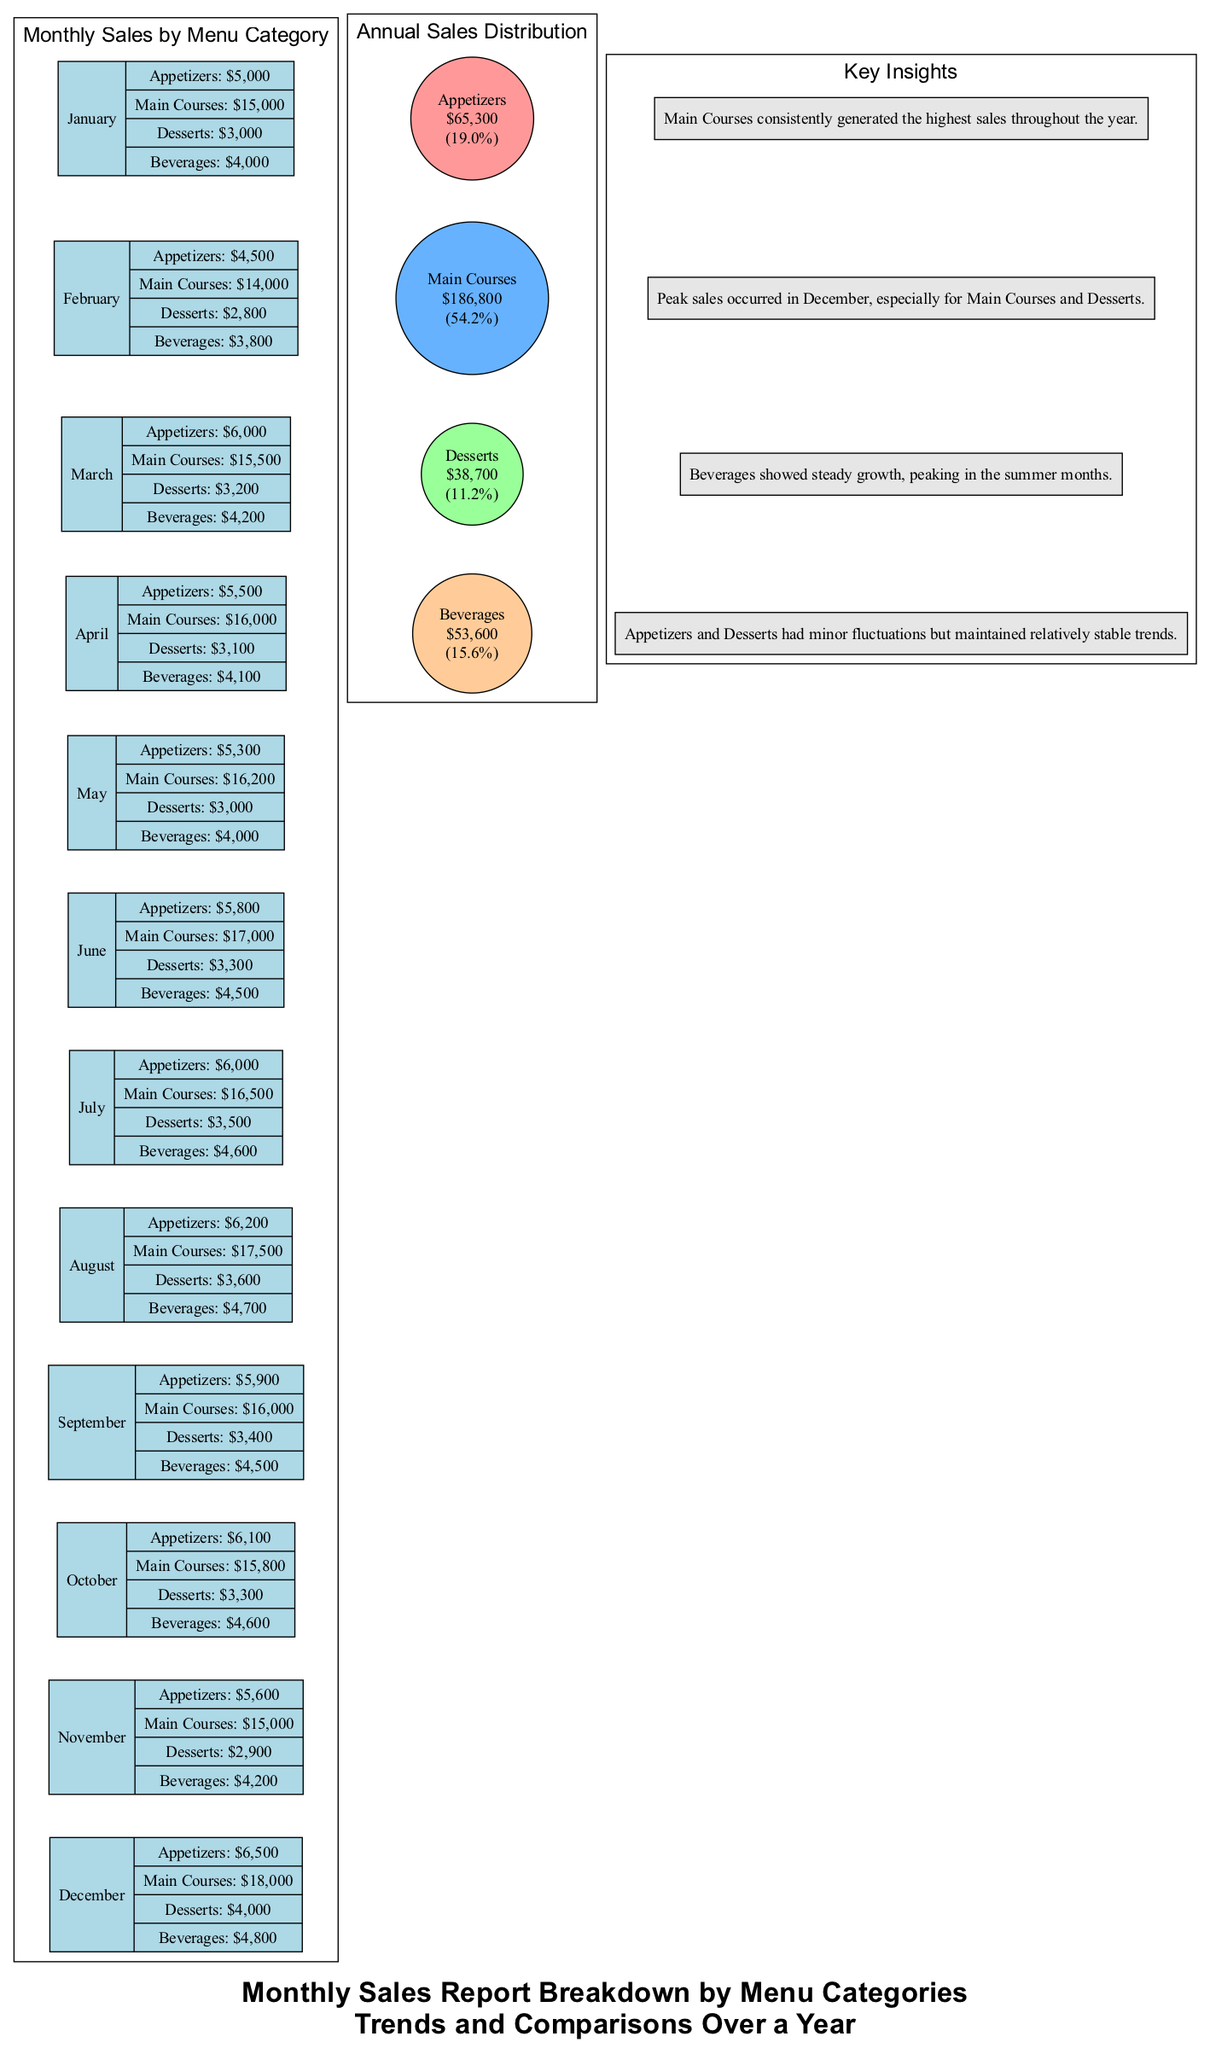What is the highest monthly sales figure for Main Courses? Looking at the bar graph, I find that the highest sales for Main Courses occur in December with a value of 18000.
Answer: 18000 Which month recorded the least sales for Desserts? By reviewing the bar graph, I see that the month with the least sales for Desserts is November, which has sales of 2900.
Answer: November What percentage of total sales does Beverages represent in the Annual Sales Distribution? The pie chart shows that Beverages totaled 53600 in sales. To find the percentage, first, calculate the total sales (65300 + 186800 + 38700 + 53600 = 306400). Then, calculate the percentage (53600 / 306400 * 100), resulting in approximately 17.5%.
Answer: 17.5% What trend is observed for Appetizers over the year? By examining the bar graph, it's clear that Appetizers exhibit minor fluctuations but overall maintain a relatively stable trend, without significant spikes or drops, averaging around 5000-6500 in sales throughout the year.
Answer: Stable trend In which month did Beverages show peak sales? From the bar graph, July shows the highest sales for Beverages at 4600.
Answer: July What is the total sales figure for Desserts over the entire year? To find the total sales for Desserts, I sum the monthly figures: 3000 + 2800 + 3200 + 3100 + 3000 + 3300 + 3500 + 3600 + 3400 + 3300 + 2900 + 4000, which totals 38700.
Answer: 38700 Which category had the lowest annual sales total? Reviewing the pie chart's sales distribution, Desserts have the lowest sales total at 38700 compared to other categories.
Answer: Desserts What can be inferred about the popularity of Main Courses compared to Appetizers based on annual sales? The pie chart indicates that Main Courses account for a significantly larger share of annual sales (186800) compared to Appetizers (65300), indicating higher popularity.
Answer: More popular 